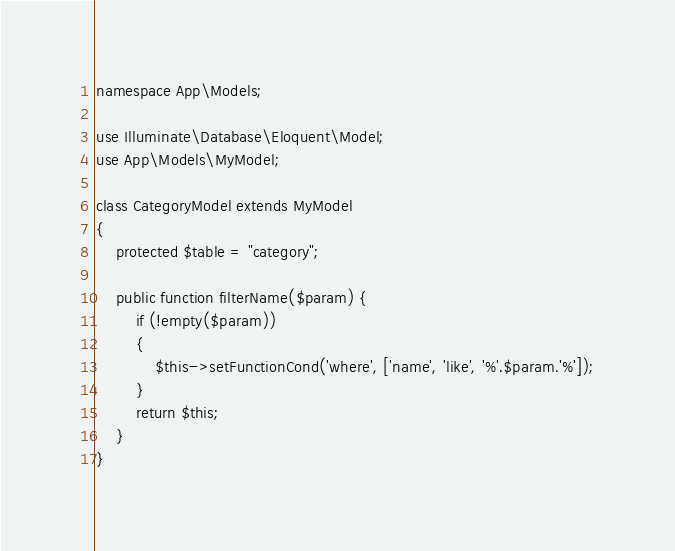Convert code to text. <code><loc_0><loc_0><loc_500><loc_500><_PHP_>
namespace App\Models;

use Illuminate\Database\Eloquent\Model;
use App\Models\MyModel;

class CategoryModel extends MyModel
{
    protected $table = "category";

    public function filterName($param) {
    	if (!empty($param))
    	{
    		$this->setFunctionCond('where', ['name', 'like', '%'.$param.'%']);
    	}
    	return $this;
    }
}
</code> 